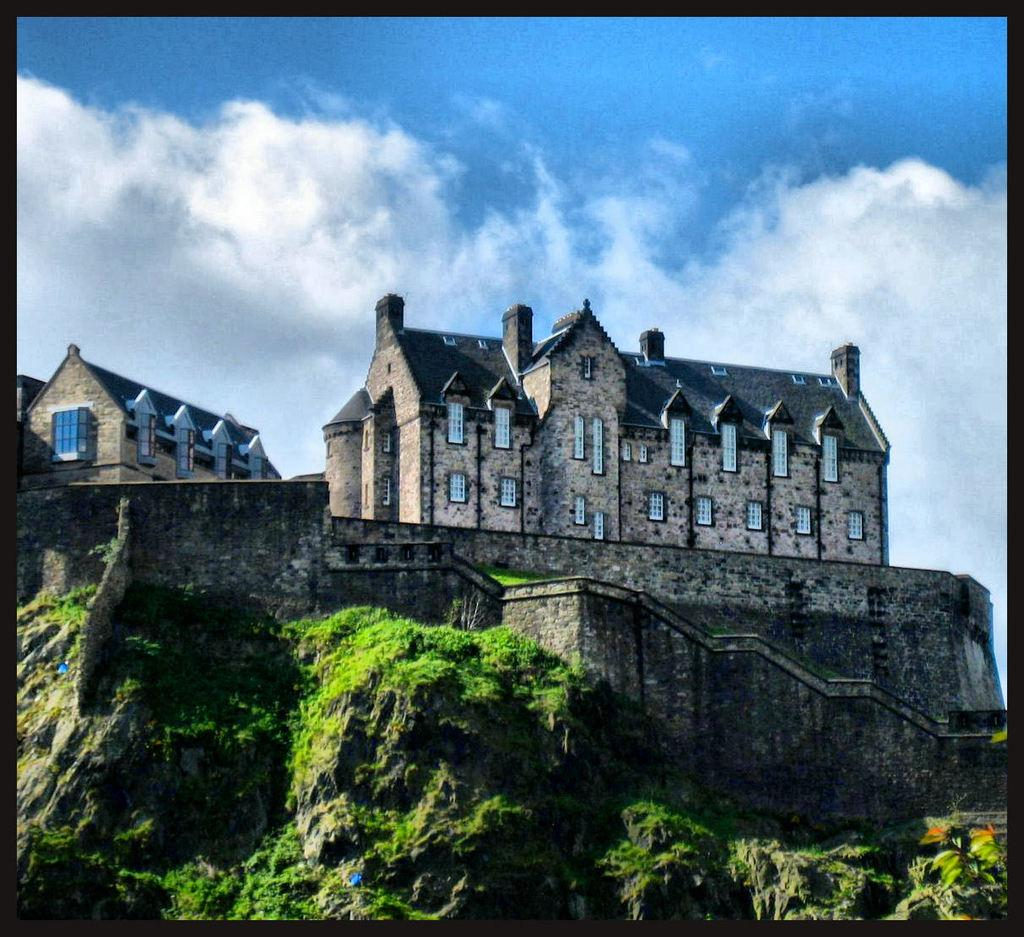What type of structure is visible in the image? There is a building in the image. What features can be seen on the building? The building has windows and doors. What is located at the bottom of the image? There are mountains at the bottom of the image. What is visible in the sky at the top of the image? There are clouds in the sky at the top of the image. What type of bean is being cooked in the image? There is no bean present in the image; it features a building, mountains, and clouds. Can you tell me how many hats are visible in the image? There are no hats present in the image. 